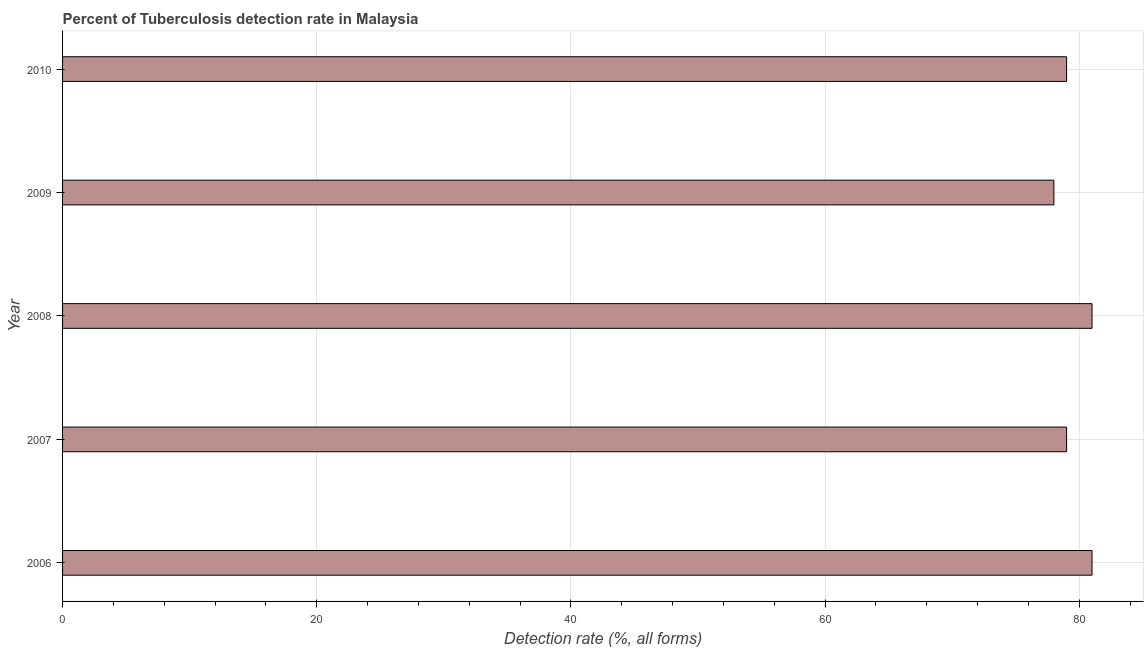Does the graph contain any zero values?
Offer a terse response. No. What is the title of the graph?
Make the answer very short. Percent of Tuberculosis detection rate in Malaysia. What is the label or title of the X-axis?
Offer a terse response. Detection rate (%, all forms). Across all years, what is the minimum detection rate of tuberculosis?
Your answer should be compact. 78. What is the sum of the detection rate of tuberculosis?
Provide a succinct answer. 398. What is the difference between the detection rate of tuberculosis in 2008 and 2009?
Your answer should be very brief. 3. What is the average detection rate of tuberculosis per year?
Provide a short and direct response. 79. What is the median detection rate of tuberculosis?
Your answer should be very brief. 79. What is the ratio of the detection rate of tuberculosis in 2006 to that in 2010?
Keep it short and to the point. 1.02. Is the detection rate of tuberculosis in 2007 less than that in 2008?
Ensure brevity in your answer.  Yes. Is the difference between the detection rate of tuberculosis in 2008 and 2009 greater than the difference between any two years?
Ensure brevity in your answer.  Yes. What is the difference between the highest and the second highest detection rate of tuberculosis?
Ensure brevity in your answer.  0. Is the sum of the detection rate of tuberculosis in 2006 and 2010 greater than the maximum detection rate of tuberculosis across all years?
Ensure brevity in your answer.  Yes. What is the difference between the highest and the lowest detection rate of tuberculosis?
Offer a very short reply. 3. In how many years, is the detection rate of tuberculosis greater than the average detection rate of tuberculosis taken over all years?
Ensure brevity in your answer.  2. How many bars are there?
Make the answer very short. 5. What is the difference between two consecutive major ticks on the X-axis?
Offer a very short reply. 20. What is the Detection rate (%, all forms) in 2007?
Offer a terse response. 79. What is the Detection rate (%, all forms) in 2008?
Give a very brief answer. 81. What is the Detection rate (%, all forms) in 2010?
Make the answer very short. 79. What is the difference between the Detection rate (%, all forms) in 2007 and 2008?
Your answer should be compact. -2. What is the difference between the Detection rate (%, all forms) in 2008 and 2009?
Keep it short and to the point. 3. What is the ratio of the Detection rate (%, all forms) in 2006 to that in 2009?
Your answer should be compact. 1.04. What is the ratio of the Detection rate (%, all forms) in 2007 to that in 2008?
Provide a short and direct response. 0.97. What is the ratio of the Detection rate (%, all forms) in 2007 to that in 2009?
Keep it short and to the point. 1.01. What is the ratio of the Detection rate (%, all forms) in 2007 to that in 2010?
Your response must be concise. 1. What is the ratio of the Detection rate (%, all forms) in 2008 to that in 2009?
Provide a succinct answer. 1.04. 